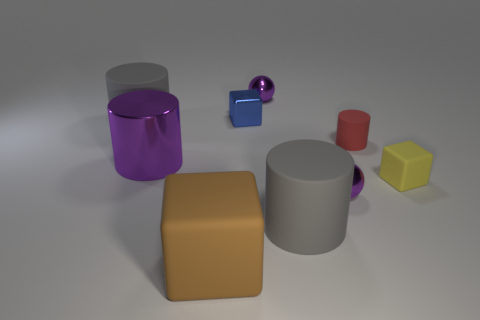What colors are the objects in this image, and can you tell me which one is the largest? The objects in the image display a variety of colors, including purple, blue, grey, red, yellow, and brown. The largest object appears to be the grey matte cylinder on the right side of the image. 